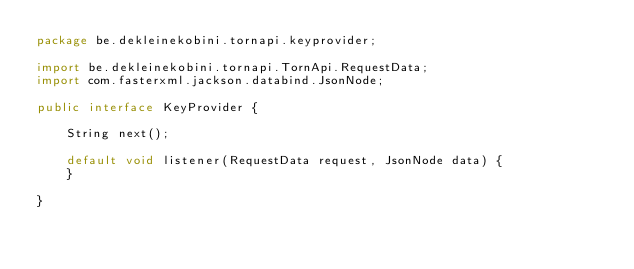Convert code to text. <code><loc_0><loc_0><loc_500><loc_500><_Java_>package be.dekleinekobini.tornapi.keyprovider;

import be.dekleinekobini.tornapi.TornApi.RequestData;
import com.fasterxml.jackson.databind.JsonNode;

public interface KeyProvider {

    String next();

    default void listener(RequestData request, JsonNode data) {
    }

}
</code> 